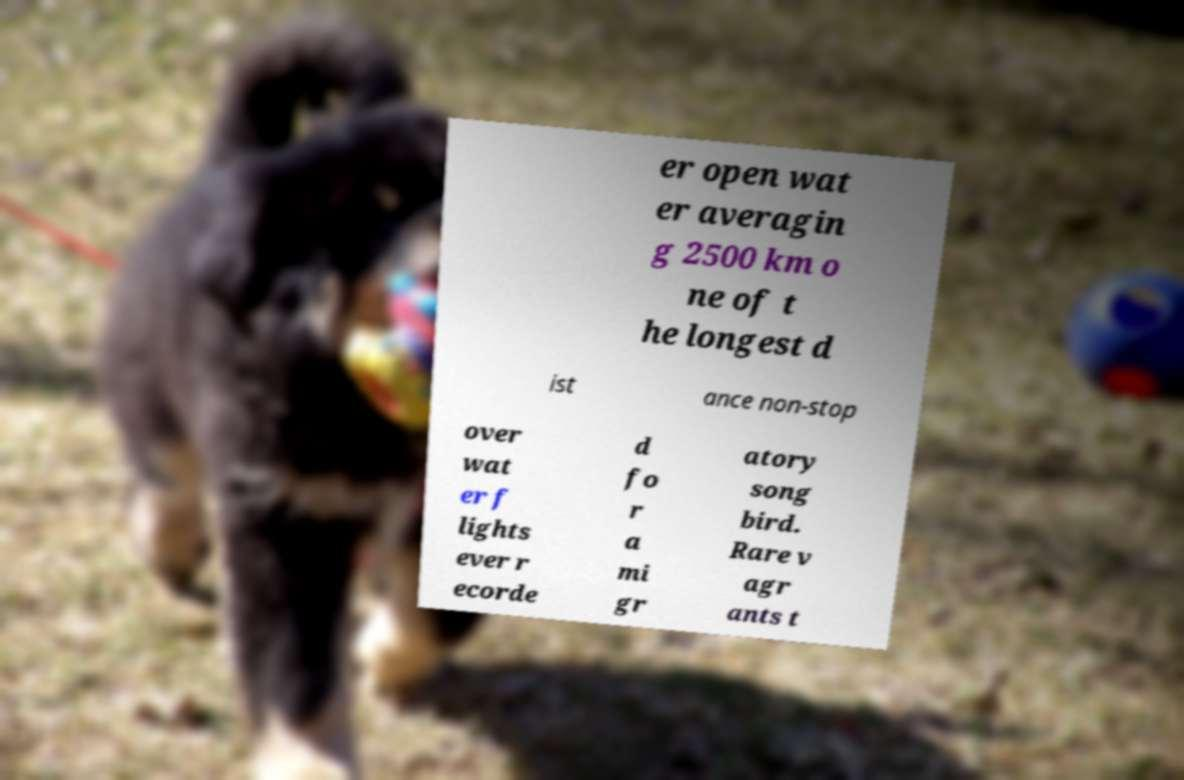There's text embedded in this image that I need extracted. Can you transcribe it verbatim? er open wat er averagin g 2500 km o ne of t he longest d ist ance non-stop over wat er f lights ever r ecorde d fo r a mi gr atory song bird. Rare v agr ants t 